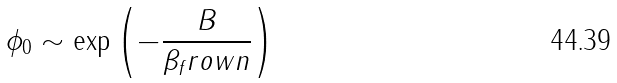<formula> <loc_0><loc_0><loc_500><loc_500>\phi _ { 0 } \sim \exp \left ( - \frac { B } { \beta _ { f } r o w n } \right )</formula> 